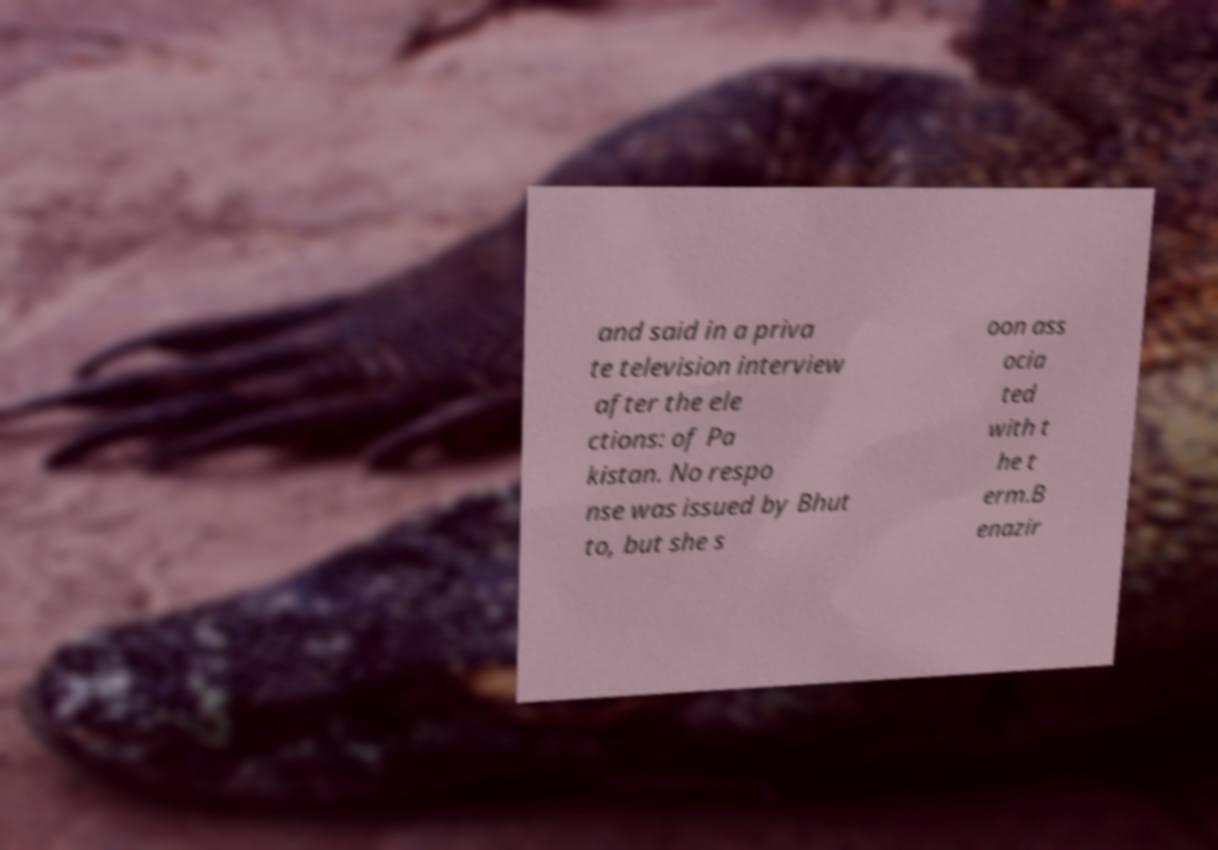What messages or text are displayed in this image? I need them in a readable, typed format. and said in a priva te television interview after the ele ctions: of Pa kistan. No respo nse was issued by Bhut to, but she s oon ass ocia ted with t he t erm.B enazir 